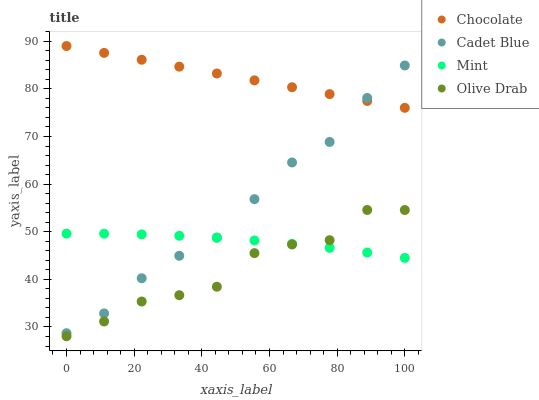Does Olive Drab have the minimum area under the curve?
Answer yes or no. Yes. Does Chocolate have the maximum area under the curve?
Answer yes or no. Yes. Does Mint have the minimum area under the curve?
Answer yes or no. No. Does Mint have the maximum area under the curve?
Answer yes or no. No. Is Chocolate the smoothest?
Answer yes or no. Yes. Is Olive Drab the roughest?
Answer yes or no. Yes. Is Mint the smoothest?
Answer yes or no. No. Is Mint the roughest?
Answer yes or no. No. Does Olive Drab have the lowest value?
Answer yes or no. Yes. Does Mint have the lowest value?
Answer yes or no. No. Does Chocolate have the highest value?
Answer yes or no. Yes. Does Olive Drab have the highest value?
Answer yes or no. No. Is Olive Drab less than Cadet Blue?
Answer yes or no. Yes. Is Cadet Blue greater than Olive Drab?
Answer yes or no. Yes. Does Mint intersect Cadet Blue?
Answer yes or no. Yes. Is Mint less than Cadet Blue?
Answer yes or no. No. Is Mint greater than Cadet Blue?
Answer yes or no. No. Does Olive Drab intersect Cadet Blue?
Answer yes or no. No. 